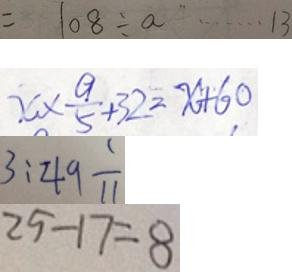<formula> <loc_0><loc_0><loc_500><loc_500>= 1 0 8 \div a \cdots 1 3 
 x \times \frac { 9 } { 5 } + 3 2 = x + 6 0 
 3 : 4 9 \frac { 1 } { 1 1 } 
 2 5 - 1 7 = 8</formula> 